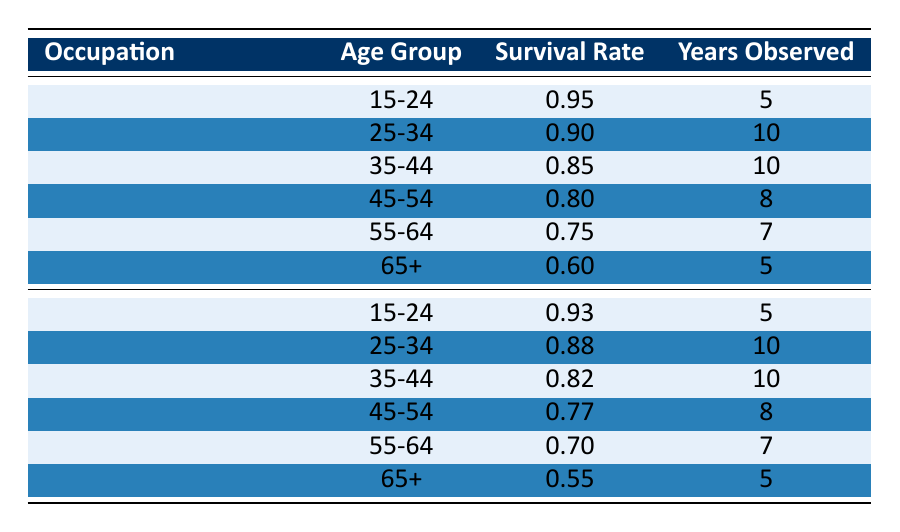What is the survival rate for commercial fishermen aged 35-44? The table lists the survival rates for different age groups of commercial fishermen. For the age group 35-44, the survival rate is directly provided as 0.85.
Answer: 0.85 What age group has the highest survival rate among deckhands? By checking the table, we see that the survival rate for deckhands is highest for the age group 15-24, which is 0.93.
Answer: 15-24 What is the difference in survival rates between commercial fishermen aged 45-54 and deckhands aged 45-54? The survival rate for commercial fishermen aged 45-54 is 0.80, while for deckhands in the same age group, it is 0.77. The difference is 0.80 - 0.77 = 0.03.
Answer: 0.03 Are the survival rates generally higher for commercial fishermen than for deckhands in the 25-34 age group? For the 25-34 age group, the survival rate for commercial fishermen is 0.90 while for deckhands, it is 0.88. Since 0.90 is greater than 0.88, the statement is true.
Answer: Yes What is the average survival rate for deckhands across all age groups? The survival rates for deckhands across age groups are 0.93, 0.88, 0.82, 0.77, 0.70, and 0.55. Summing these values gives us 0.93 + 0.88 + 0.82 + 0.77 + 0.70 + 0.55 = 4.65. Dividing by the number of age groups (6) results in an average of 4.65 / 6 = 0.775.
Answer: 0.775 Is the survival rate for fishermen aged 65 and older lower than that of deckhands in the same age group? The survival rate for commercial fishermen aged 65+ is 0.60, while for deckhands, it is 0.55. Since 0.60 is greater than 0.55, the statement is false.
Answer: No What is the lowest survival rate among commercial fishermen and in which age group does it occur? In the table, the lowest survival rate among commercial fishermen is 0.60 for the age group 65+.
Answer: 0.60 at 65+ 